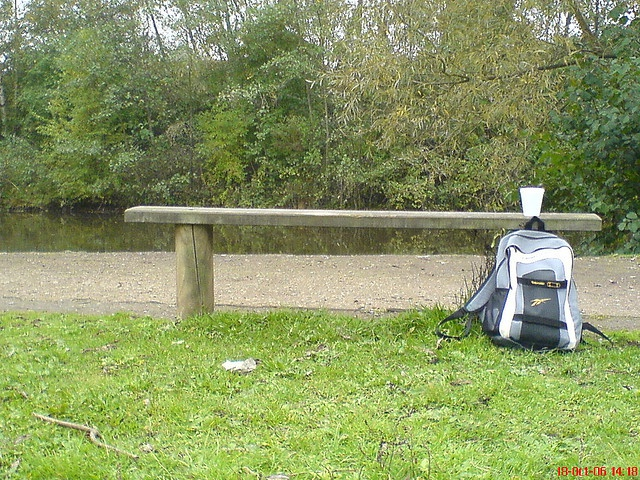Describe the objects in this image and their specific colors. I can see bench in darkgray, gray, and ivory tones, backpack in darkgray, white, gray, and black tones, and cup in darkgray, white, and gray tones in this image. 